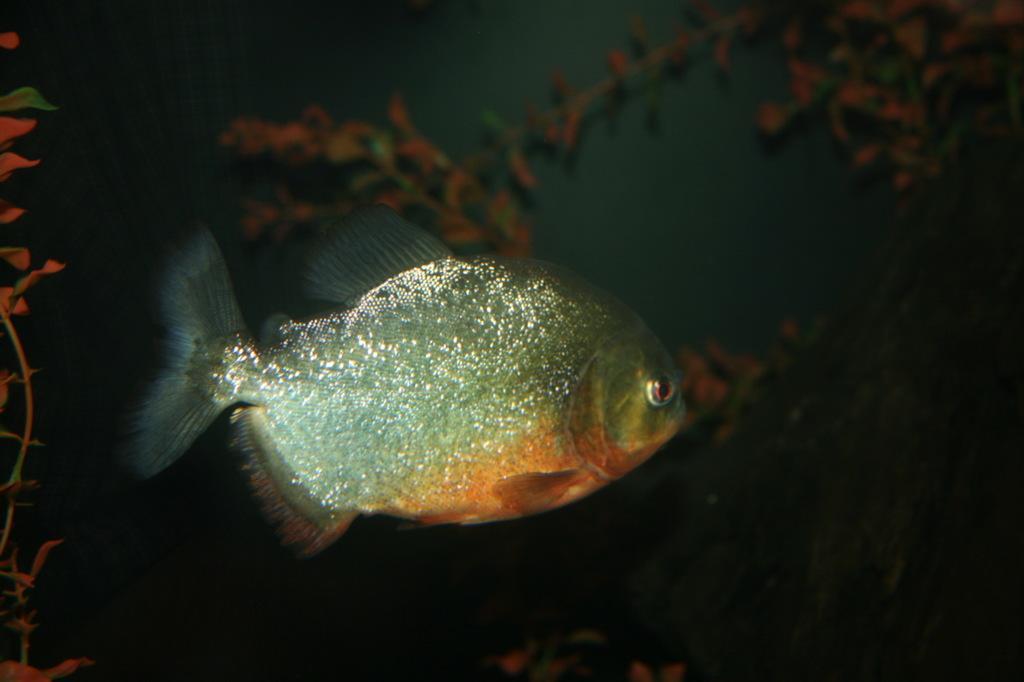Please provide a concise description of this image. This is an inside view of the water. Here I can see a fish facing towards the right side. In the background there are some plants. 